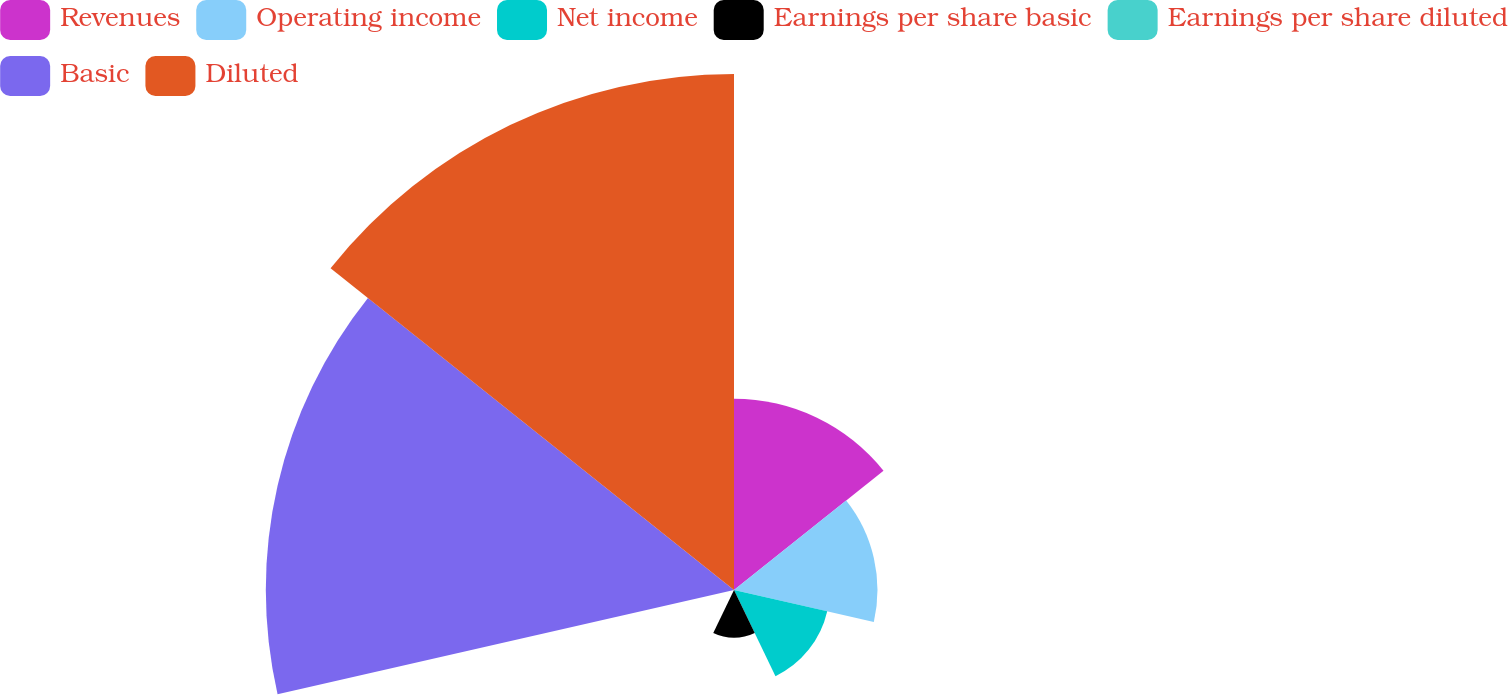Convert chart to OTSL. <chart><loc_0><loc_0><loc_500><loc_500><pie_chart><fcel>Revenues<fcel>Operating income<fcel>Net income<fcel>Earnings per share basic<fcel>Earnings per share diluted<fcel>Basic<fcel>Diluted<nl><fcel>13.08%<fcel>9.81%<fcel>6.54%<fcel>3.27%<fcel>0.0%<fcel>32.02%<fcel>35.29%<nl></chart> 